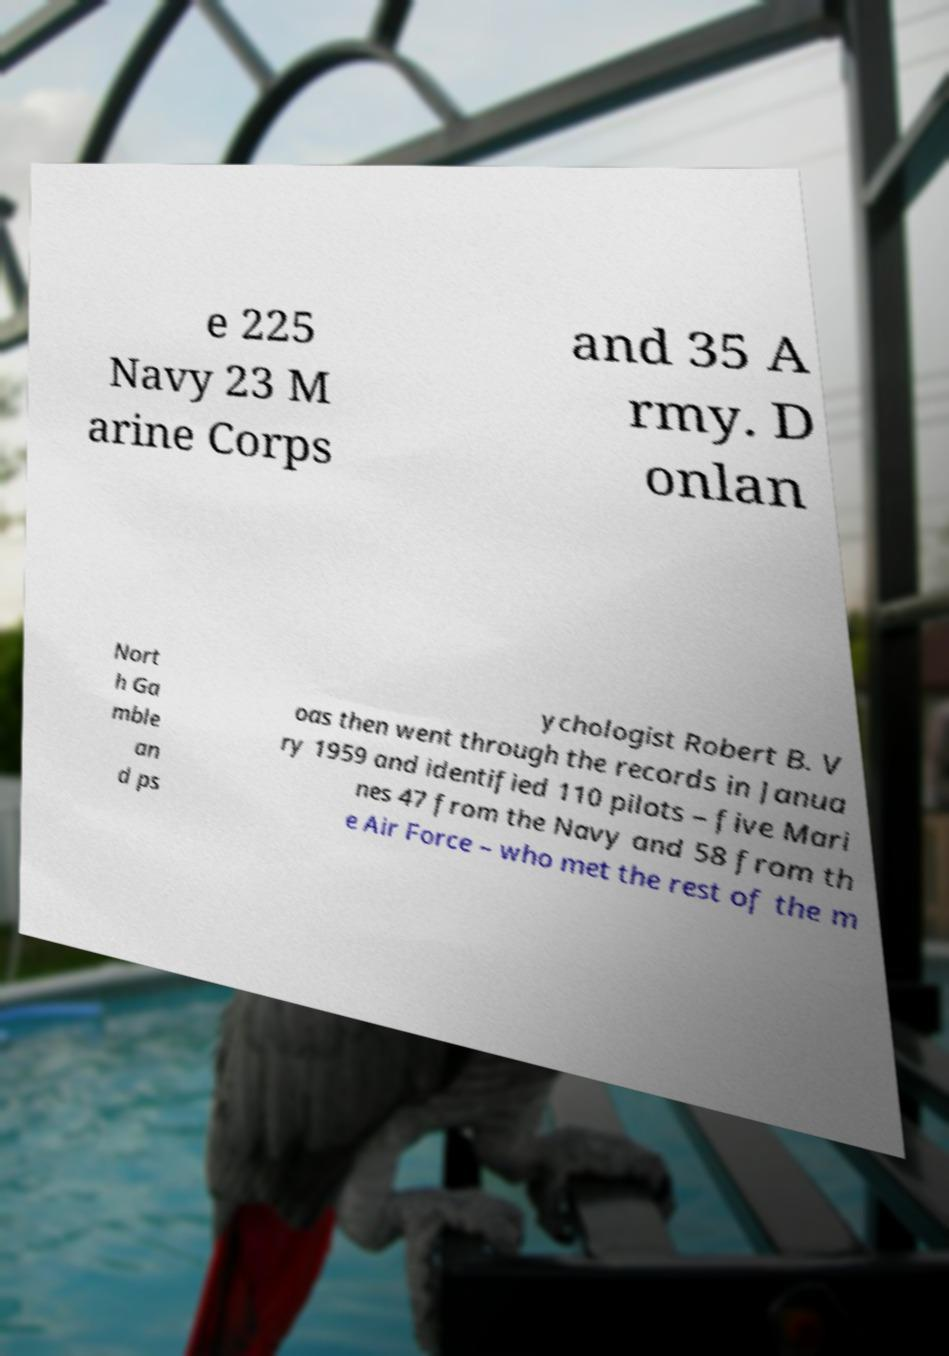What messages or text are displayed in this image? I need them in a readable, typed format. e 225 Navy 23 M arine Corps and 35 A rmy. D onlan Nort h Ga mble an d ps ychologist Robert B. V oas then went through the records in Janua ry 1959 and identified 110 pilots – five Mari nes 47 from the Navy and 58 from th e Air Force – who met the rest of the m 